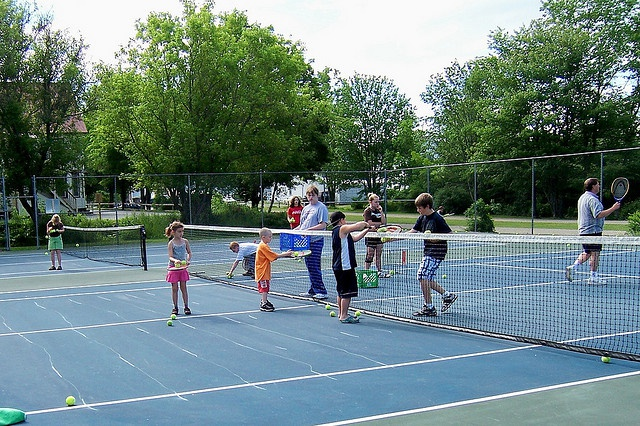Describe the objects in this image and their specific colors. I can see people in olive, black, gray, navy, and darkgray tones, people in olive, black, gray, darkgray, and white tones, people in olive, black, lightgray, gray, and darkgray tones, people in olive, gray, darkgray, black, and purple tones, and people in olive, navy, black, gray, and lavender tones in this image. 